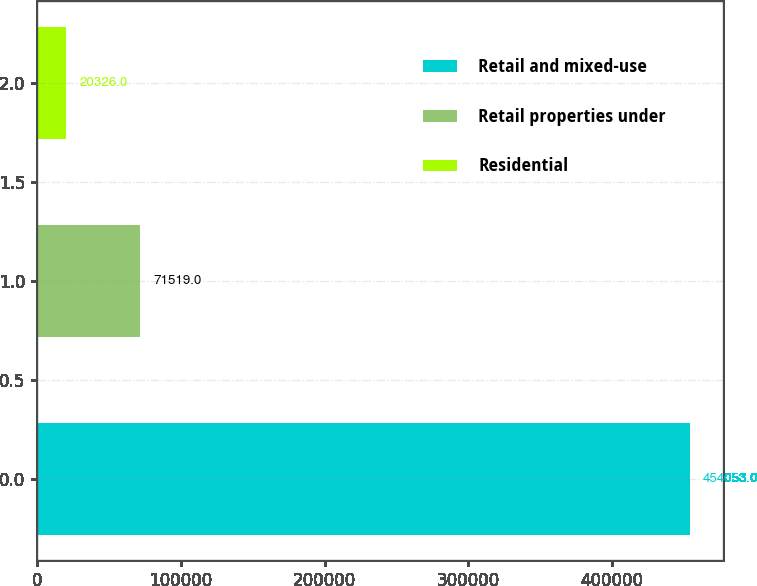<chart> <loc_0><loc_0><loc_500><loc_500><bar_chart><fcel>Retail and mixed-use<fcel>Retail properties under<fcel>Residential<nl><fcel>454053<fcel>71519<fcel>20326<nl></chart> 